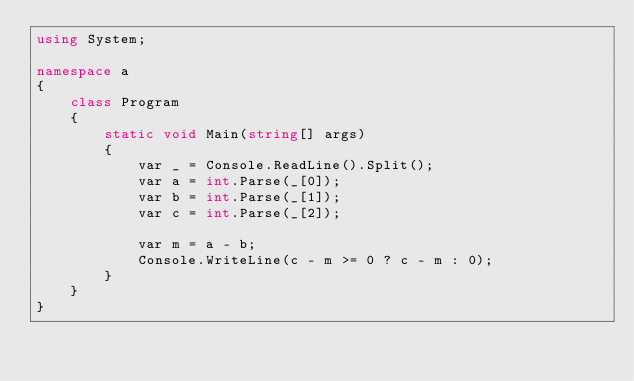Convert code to text. <code><loc_0><loc_0><loc_500><loc_500><_C#_>using System;

namespace a
{
    class Program
    {
        static void Main(string[] args)
        {
            var _ = Console.ReadLine().Split();
            var a = int.Parse(_[0]);
            var b = int.Parse(_[1]);
            var c = int.Parse(_[2]);

            var m = a - b;
            Console.WriteLine(c - m >= 0 ? c - m : 0);
        }
    }
}
</code> 